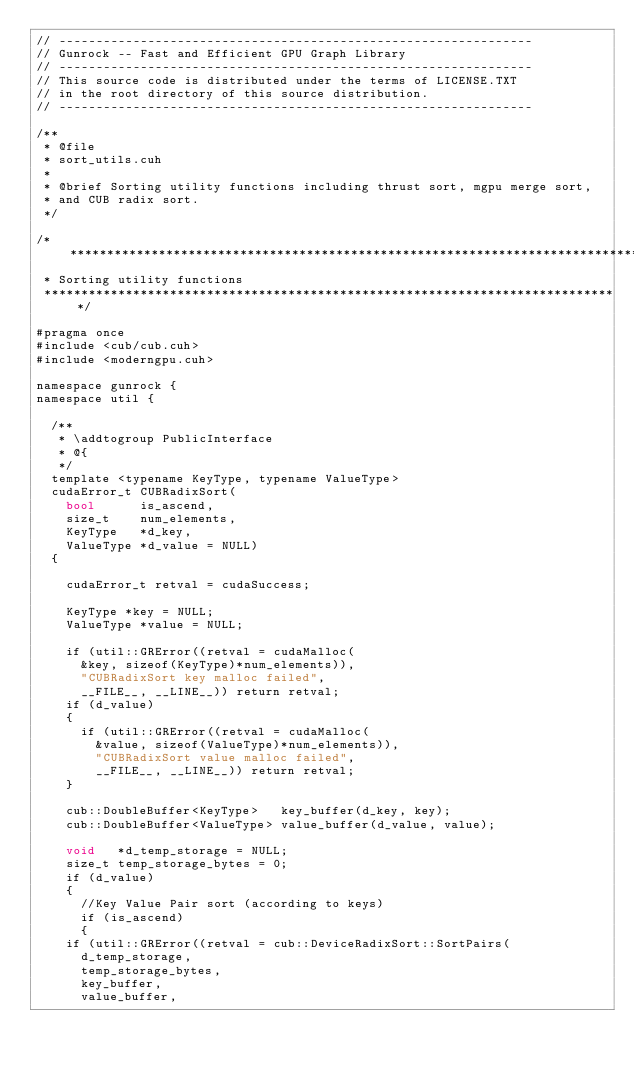<code> <loc_0><loc_0><loc_500><loc_500><_Cuda_>// ----------------------------------------------------------------
// Gunrock -- Fast and Efficient GPU Graph Library
// ----------------------------------------------------------------
// This source code is distributed under the terms of LICENSE.TXT
// in the root directory of this source distribution.
// ----------------------------------------------------------------

/**
 * @file
 * sort_utils.cuh
 *
 * @brief Sorting utility functions including thrust sort, mgpu merge sort,
 * and CUB radix sort.
 */

/******************************************************************************
 * Sorting utility functions
 ******************************************************************************/

#pragma once
#include <cub/cub.cuh>
#include <moderngpu.cuh>

namespace gunrock {
namespace util {

  /**
   * \addtogroup PublicInterface
   * @{
   */
  template <typename KeyType, typename ValueType>
  cudaError_t CUBRadixSort(
    bool      is_ascend,
    size_t    num_elements,
    KeyType   *d_key,
    ValueType *d_value = NULL)
  {

    cudaError_t retval = cudaSuccess;

    KeyType *key = NULL;
    ValueType *value = NULL;

    if (util::GRError((retval = cudaMalloc(
      &key, sizeof(KeyType)*num_elements)),
      "CUBRadixSort key malloc failed",
      __FILE__, __LINE__)) return retval;
    if (d_value)
    {
      if (util::GRError((retval = cudaMalloc(
        &value, sizeof(ValueType)*num_elements)),
        "CUBRadixSort value malloc failed",
        __FILE__, __LINE__)) return retval;
    }

    cub::DoubleBuffer<KeyType>   key_buffer(d_key, key);
    cub::DoubleBuffer<ValueType> value_buffer(d_value, value);

    void   *d_temp_storage = NULL;
    size_t temp_storage_bytes = 0;
    if (d_value)
    {
      //Key Value Pair sort (according to keys)
      if (is_ascend)
      {
	if (util::GRError((retval = cub::DeviceRadixSort::SortPairs(
	  d_temp_storage,
	  temp_storage_bytes,
	  key_buffer,
	  value_buffer,</code> 